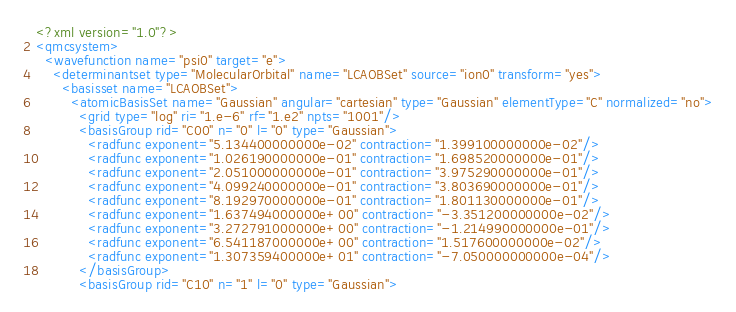Convert code to text. <code><loc_0><loc_0><loc_500><loc_500><_XML_><?xml version="1.0"?>
<qmcsystem>
  <wavefunction name="psi0" target="e">
    <determinantset type="MolecularOrbital" name="LCAOBSet" source="ion0" transform="yes">
      <basisset name="LCAOBSet">
        <atomicBasisSet name="Gaussian" angular="cartesian" type="Gaussian" elementType="C" normalized="no">
          <grid type="log" ri="1.e-6" rf="1.e2" npts="1001"/>
          <basisGroup rid="C00" n="0" l="0" type="Gaussian">
            <radfunc exponent="5.134400000000e-02" contraction="1.399100000000e-02"/>
            <radfunc exponent="1.026190000000e-01" contraction="1.698520000000e-01"/>
            <radfunc exponent="2.051000000000e-01" contraction="3.975290000000e-01"/>
            <radfunc exponent="4.099240000000e-01" contraction="3.803690000000e-01"/>
            <radfunc exponent="8.192970000000e-01" contraction="1.801130000000e-01"/>
            <radfunc exponent="1.637494000000e+00" contraction="-3.351200000000e-02"/>
            <radfunc exponent="3.272791000000e+00" contraction="-1.214990000000e-01"/>
            <radfunc exponent="6.541187000000e+00" contraction="1.517600000000e-02"/>
            <radfunc exponent="1.307359400000e+01" contraction="-7.050000000000e-04"/>
          </basisGroup>
          <basisGroup rid="C10" n="1" l="0" type="Gaussian"></code> 